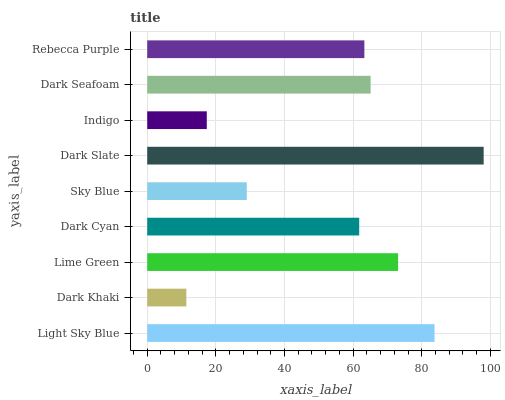Is Dark Khaki the minimum?
Answer yes or no. Yes. Is Dark Slate the maximum?
Answer yes or no. Yes. Is Lime Green the minimum?
Answer yes or no. No. Is Lime Green the maximum?
Answer yes or no. No. Is Lime Green greater than Dark Khaki?
Answer yes or no. Yes. Is Dark Khaki less than Lime Green?
Answer yes or no. Yes. Is Dark Khaki greater than Lime Green?
Answer yes or no. No. Is Lime Green less than Dark Khaki?
Answer yes or no. No. Is Rebecca Purple the high median?
Answer yes or no. Yes. Is Rebecca Purple the low median?
Answer yes or no. Yes. Is Dark Seafoam the high median?
Answer yes or no. No. Is Light Sky Blue the low median?
Answer yes or no. No. 